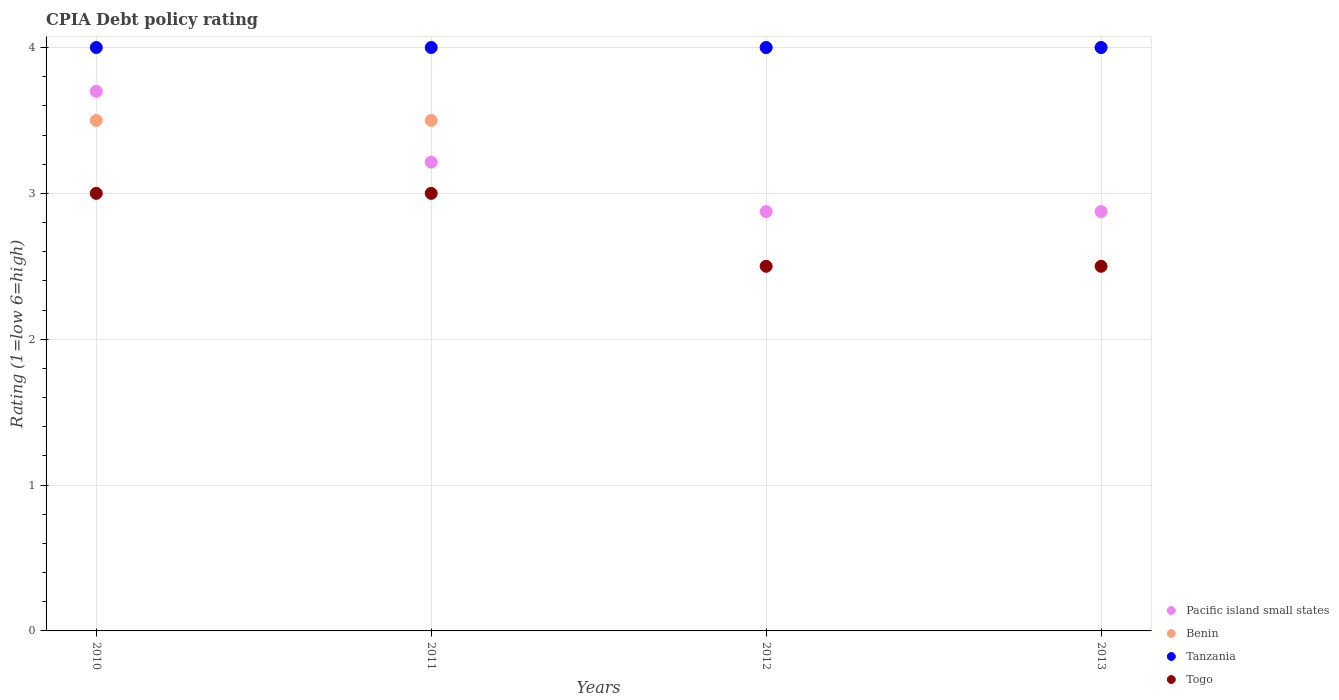What is the CPIA rating in Pacific island small states in 2011?
Offer a terse response. 3.21. Across all years, what is the maximum CPIA rating in Togo?
Make the answer very short. 3. In which year was the CPIA rating in Tanzania maximum?
Make the answer very short. 2010. What is the total CPIA rating in Pacific island small states in the graph?
Your answer should be compact. 12.66. What is the ratio of the CPIA rating in Togo in 2010 to that in 2013?
Your response must be concise. 1.2. Is the difference between the CPIA rating in Benin in 2010 and 2013 greater than the difference between the CPIA rating in Tanzania in 2010 and 2013?
Provide a succinct answer. No. In how many years, is the CPIA rating in Benin greater than the average CPIA rating in Benin taken over all years?
Provide a succinct answer. 2. Is the sum of the CPIA rating in Tanzania in 2010 and 2011 greater than the maximum CPIA rating in Togo across all years?
Keep it short and to the point. Yes. Is it the case that in every year, the sum of the CPIA rating in Tanzania and CPIA rating in Benin  is greater than the sum of CPIA rating in Pacific island small states and CPIA rating in Togo?
Your answer should be very brief. No. Is the CPIA rating in Tanzania strictly greater than the CPIA rating in Togo over the years?
Offer a very short reply. Yes. Is the CPIA rating in Togo strictly less than the CPIA rating in Pacific island small states over the years?
Offer a very short reply. Yes. How many dotlines are there?
Your answer should be compact. 4. Does the graph contain grids?
Provide a succinct answer. Yes. Where does the legend appear in the graph?
Ensure brevity in your answer.  Bottom right. How many legend labels are there?
Provide a short and direct response. 4. How are the legend labels stacked?
Offer a very short reply. Vertical. What is the title of the graph?
Provide a succinct answer. CPIA Debt policy rating. What is the label or title of the X-axis?
Your response must be concise. Years. What is the label or title of the Y-axis?
Your answer should be very brief. Rating (1=low 6=high). What is the Rating (1=low 6=high) of Tanzania in 2010?
Your answer should be very brief. 4. What is the Rating (1=low 6=high) of Pacific island small states in 2011?
Your answer should be compact. 3.21. What is the Rating (1=low 6=high) of Benin in 2011?
Ensure brevity in your answer.  3.5. What is the Rating (1=low 6=high) of Togo in 2011?
Give a very brief answer. 3. What is the Rating (1=low 6=high) of Pacific island small states in 2012?
Provide a short and direct response. 2.88. What is the Rating (1=low 6=high) of Togo in 2012?
Your response must be concise. 2.5. What is the Rating (1=low 6=high) of Pacific island small states in 2013?
Offer a very short reply. 2.88. Across all years, what is the maximum Rating (1=low 6=high) in Benin?
Give a very brief answer. 4. Across all years, what is the maximum Rating (1=low 6=high) in Togo?
Ensure brevity in your answer.  3. Across all years, what is the minimum Rating (1=low 6=high) of Pacific island small states?
Provide a succinct answer. 2.88. Across all years, what is the minimum Rating (1=low 6=high) of Benin?
Provide a succinct answer. 3.5. What is the total Rating (1=low 6=high) in Pacific island small states in the graph?
Provide a succinct answer. 12.66. What is the difference between the Rating (1=low 6=high) of Pacific island small states in 2010 and that in 2011?
Your answer should be very brief. 0.49. What is the difference between the Rating (1=low 6=high) in Benin in 2010 and that in 2011?
Keep it short and to the point. 0. What is the difference between the Rating (1=low 6=high) of Tanzania in 2010 and that in 2011?
Give a very brief answer. 0. What is the difference between the Rating (1=low 6=high) in Pacific island small states in 2010 and that in 2012?
Keep it short and to the point. 0.82. What is the difference between the Rating (1=low 6=high) of Tanzania in 2010 and that in 2012?
Your answer should be compact. 0. What is the difference between the Rating (1=low 6=high) in Togo in 2010 and that in 2012?
Offer a terse response. 0.5. What is the difference between the Rating (1=low 6=high) in Pacific island small states in 2010 and that in 2013?
Offer a very short reply. 0.82. What is the difference between the Rating (1=low 6=high) of Benin in 2010 and that in 2013?
Keep it short and to the point. -0.5. What is the difference between the Rating (1=low 6=high) in Pacific island small states in 2011 and that in 2012?
Provide a succinct answer. 0.34. What is the difference between the Rating (1=low 6=high) of Benin in 2011 and that in 2012?
Offer a terse response. -0.5. What is the difference between the Rating (1=low 6=high) of Pacific island small states in 2011 and that in 2013?
Your answer should be compact. 0.34. What is the difference between the Rating (1=low 6=high) of Togo in 2011 and that in 2013?
Offer a terse response. 0.5. What is the difference between the Rating (1=low 6=high) in Pacific island small states in 2012 and that in 2013?
Keep it short and to the point. 0. What is the difference between the Rating (1=low 6=high) in Benin in 2012 and that in 2013?
Your answer should be compact. 0. What is the difference between the Rating (1=low 6=high) in Tanzania in 2012 and that in 2013?
Your answer should be compact. 0. What is the difference between the Rating (1=low 6=high) of Togo in 2012 and that in 2013?
Provide a short and direct response. 0. What is the difference between the Rating (1=low 6=high) of Pacific island small states in 2010 and the Rating (1=low 6=high) of Benin in 2011?
Give a very brief answer. 0.2. What is the difference between the Rating (1=low 6=high) of Pacific island small states in 2010 and the Rating (1=low 6=high) of Tanzania in 2011?
Your response must be concise. -0.3. What is the difference between the Rating (1=low 6=high) of Pacific island small states in 2010 and the Rating (1=low 6=high) of Togo in 2011?
Your answer should be very brief. 0.7. What is the difference between the Rating (1=low 6=high) in Pacific island small states in 2010 and the Rating (1=low 6=high) in Benin in 2012?
Your response must be concise. -0.3. What is the difference between the Rating (1=low 6=high) in Pacific island small states in 2010 and the Rating (1=low 6=high) in Tanzania in 2012?
Your response must be concise. -0.3. What is the difference between the Rating (1=low 6=high) of Pacific island small states in 2010 and the Rating (1=low 6=high) of Togo in 2012?
Offer a very short reply. 1.2. What is the difference between the Rating (1=low 6=high) in Benin in 2010 and the Rating (1=low 6=high) in Tanzania in 2012?
Keep it short and to the point. -0.5. What is the difference between the Rating (1=low 6=high) in Pacific island small states in 2010 and the Rating (1=low 6=high) in Tanzania in 2013?
Offer a very short reply. -0.3. What is the difference between the Rating (1=low 6=high) in Pacific island small states in 2010 and the Rating (1=low 6=high) in Togo in 2013?
Offer a terse response. 1.2. What is the difference between the Rating (1=low 6=high) in Benin in 2010 and the Rating (1=low 6=high) in Tanzania in 2013?
Ensure brevity in your answer.  -0.5. What is the difference between the Rating (1=low 6=high) in Benin in 2010 and the Rating (1=low 6=high) in Togo in 2013?
Make the answer very short. 1. What is the difference between the Rating (1=low 6=high) of Tanzania in 2010 and the Rating (1=low 6=high) of Togo in 2013?
Make the answer very short. 1.5. What is the difference between the Rating (1=low 6=high) in Pacific island small states in 2011 and the Rating (1=low 6=high) in Benin in 2012?
Offer a very short reply. -0.79. What is the difference between the Rating (1=low 6=high) of Pacific island small states in 2011 and the Rating (1=low 6=high) of Tanzania in 2012?
Offer a very short reply. -0.79. What is the difference between the Rating (1=low 6=high) in Pacific island small states in 2011 and the Rating (1=low 6=high) in Togo in 2012?
Offer a very short reply. 0.71. What is the difference between the Rating (1=low 6=high) of Tanzania in 2011 and the Rating (1=low 6=high) of Togo in 2012?
Keep it short and to the point. 1.5. What is the difference between the Rating (1=low 6=high) in Pacific island small states in 2011 and the Rating (1=low 6=high) in Benin in 2013?
Your answer should be very brief. -0.79. What is the difference between the Rating (1=low 6=high) of Pacific island small states in 2011 and the Rating (1=low 6=high) of Tanzania in 2013?
Provide a short and direct response. -0.79. What is the difference between the Rating (1=low 6=high) in Benin in 2011 and the Rating (1=low 6=high) in Tanzania in 2013?
Make the answer very short. -0.5. What is the difference between the Rating (1=low 6=high) of Benin in 2011 and the Rating (1=low 6=high) of Togo in 2013?
Make the answer very short. 1. What is the difference between the Rating (1=low 6=high) in Pacific island small states in 2012 and the Rating (1=low 6=high) in Benin in 2013?
Give a very brief answer. -1.12. What is the difference between the Rating (1=low 6=high) in Pacific island small states in 2012 and the Rating (1=low 6=high) in Tanzania in 2013?
Your answer should be very brief. -1.12. What is the difference between the Rating (1=low 6=high) of Pacific island small states in 2012 and the Rating (1=low 6=high) of Togo in 2013?
Offer a very short reply. 0.38. What is the difference between the Rating (1=low 6=high) in Benin in 2012 and the Rating (1=low 6=high) in Togo in 2013?
Your answer should be very brief. 1.5. What is the average Rating (1=low 6=high) in Pacific island small states per year?
Keep it short and to the point. 3.17. What is the average Rating (1=low 6=high) of Benin per year?
Your answer should be very brief. 3.75. What is the average Rating (1=low 6=high) of Tanzania per year?
Give a very brief answer. 4. What is the average Rating (1=low 6=high) of Togo per year?
Offer a very short reply. 2.75. In the year 2010, what is the difference between the Rating (1=low 6=high) of Pacific island small states and Rating (1=low 6=high) of Togo?
Make the answer very short. 0.7. In the year 2010, what is the difference between the Rating (1=low 6=high) of Benin and Rating (1=low 6=high) of Tanzania?
Give a very brief answer. -0.5. In the year 2010, what is the difference between the Rating (1=low 6=high) in Benin and Rating (1=low 6=high) in Togo?
Ensure brevity in your answer.  0.5. In the year 2010, what is the difference between the Rating (1=low 6=high) of Tanzania and Rating (1=low 6=high) of Togo?
Provide a succinct answer. 1. In the year 2011, what is the difference between the Rating (1=low 6=high) of Pacific island small states and Rating (1=low 6=high) of Benin?
Provide a succinct answer. -0.29. In the year 2011, what is the difference between the Rating (1=low 6=high) in Pacific island small states and Rating (1=low 6=high) in Tanzania?
Keep it short and to the point. -0.79. In the year 2011, what is the difference between the Rating (1=low 6=high) in Pacific island small states and Rating (1=low 6=high) in Togo?
Offer a terse response. 0.21. In the year 2011, what is the difference between the Rating (1=low 6=high) in Benin and Rating (1=low 6=high) in Tanzania?
Your answer should be compact. -0.5. In the year 2011, what is the difference between the Rating (1=low 6=high) of Benin and Rating (1=low 6=high) of Togo?
Provide a short and direct response. 0.5. In the year 2012, what is the difference between the Rating (1=low 6=high) in Pacific island small states and Rating (1=low 6=high) in Benin?
Your response must be concise. -1.12. In the year 2012, what is the difference between the Rating (1=low 6=high) of Pacific island small states and Rating (1=low 6=high) of Tanzania?
Make the answer very short. -1.12. In the year 2012, what is the difference between the Rating (1=low 6=high) of Benin and Rating (1=low 6=high) of Tanzania?
Your answer should be compact. 0. In the year 2012, what is the difference between the Rating (1=low 6=high) of Benin and Rating (1=low 6=high) of Togo?
Your response must be concise. 1.5. In the year 2013, what is the difference between the Rating (1=low 6=high) in Pacific island small states and Rating (1=low 6=high) in Benin?
Your answer should be very brief. -1.12. In the year 2013, what is the difference between the Rating (1=low 6=high) in Pacific island small states and Rating (1=low 6=high) in Tanzania?
Provide a short and direct response. -1.12. In the year 2013, what is the difference between the Rating (1=low 6=high) in Benin and Rating (1=low 6=high) in Tanzania?
Provide a short and direct response. 0. In the year 2013, what is the difference between the Rating (1=low 6=high) in Tanzania and Rating (1=low 6=high) in Togo?
Your answer should be very brief. 1.5. What is the ratio of the Rating (1=low 6=high) of Pacific island small states in 2010 to that in 2011?
Keep it short and to the point. 1.15. What is the ratio of the Rating (1=low 6=high) in Tanzania in 2010 to that in 2011?
Offer a terse response. 1. What is the ratio of the Rating (1=low 6=high) of Pacific island small states in 2010 to that in 2012?
Offer a terse response. 1.29. What is the ratio of the Rating (1=low 6=high) of Pacific island small states in 2010 to that in 2013?
Offer a very short reply. 1.29. What is the ratio of the Rating (1=low 6=high) in Benin in 2010 to that in 2013?
Your answer should be very brief. 0.88. What is the ratio of the Rating (1=low 6=high) of Tanzania in 2010 to that in 2013?
Your answer should be very brief. 1. What is the ratio of the Rating (1=low 6=high) of Togo in 2010 to that in 2013?
Your answer should be very brief. 1.2. What is the ratio of the Rating (1=low 6=high) in Pacific island small states in 2011 to that in 2012?
Offer a very short reply. 1.12. What is the ratio of the Rating (1=low 6=high) of Benin in 2011 to that in 2012?
Your answer should be very brief. 0.88. What is the ratio of the Rating (1=low 6=high) in Pacific island small states in 2011 to that in 2013?
Your answer should be very brief. 1.12. What is the ratio of the Rating (1=low 6=high) in Togo in 2011 to that in 2013?
Offer a very short reply. 1.2. What is the ratio of the Rating (1=low 6=high) of Togo in 2012 to that in 2013?
Make the answer very short. 1. What is the difference between the highest and the second highest Rating (1=low 6=high) in Pacific island small states?
Offer a terse response. 0.49. What is the difference between the highest and the second highest Rating (1=low 6=high) in Benin?
Provide a succinct answer. 0. What is the difference between the highest and the second highest Rating (1=low 6=high) in Tanzania?
Your answer should be compact. 0. What is the difference between the highest and the lowest Rating (1=low 6=high) of Pacific island small states?
Your response must be concise. 0.82. What is the difference between the highest and the lowest Rating (1=low 6=high) in Benin?
Your answer should be very brief. 0.5. What is the difference between the highest and the lowest Rating (1=low 6=high) of Togo?
Ensure brevity in your answer.  0.5. 